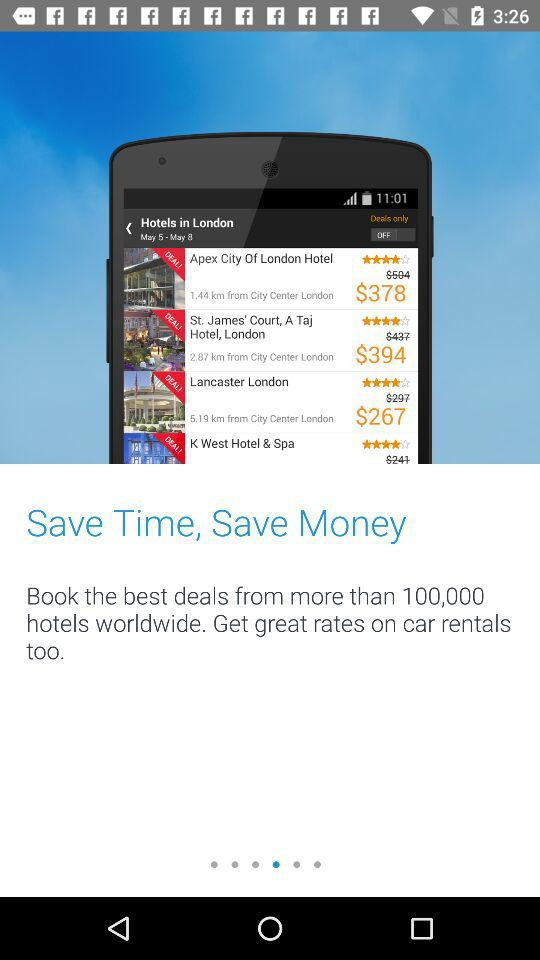What dates are selected for searching a hotel? The dates are May 5–May 8. 